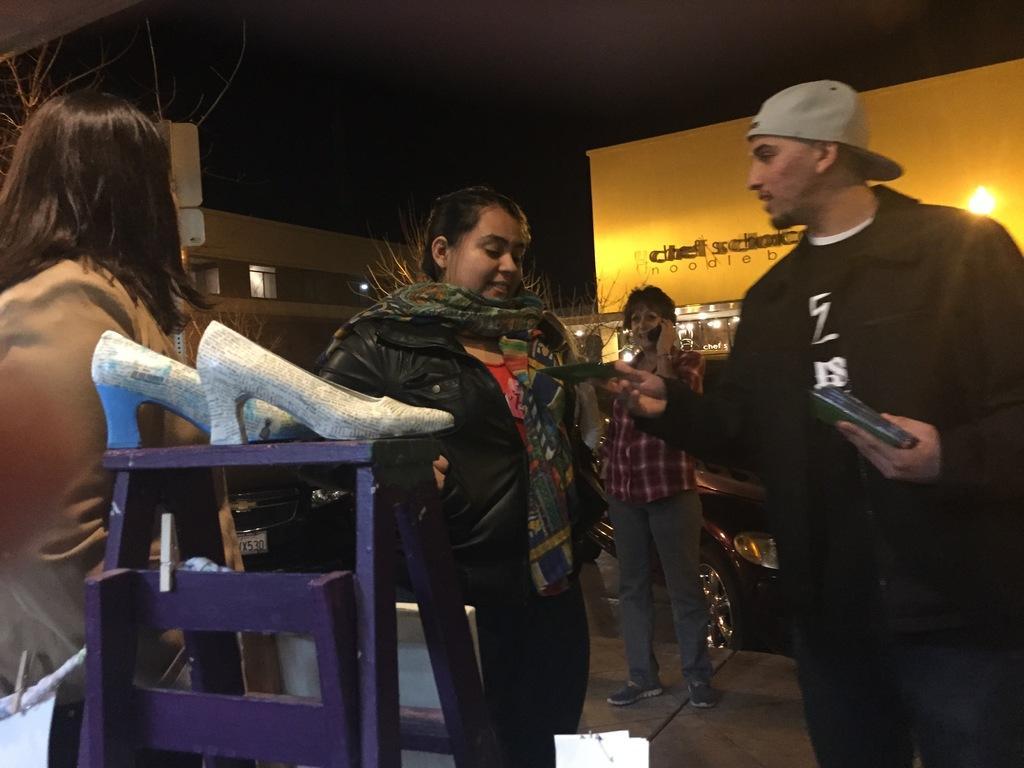Could you give a brief overview of what you see in this image? In this image there is a table on that table there are slippers, behind that there are three women and a man standing on a footpath, in the background there are shops. 